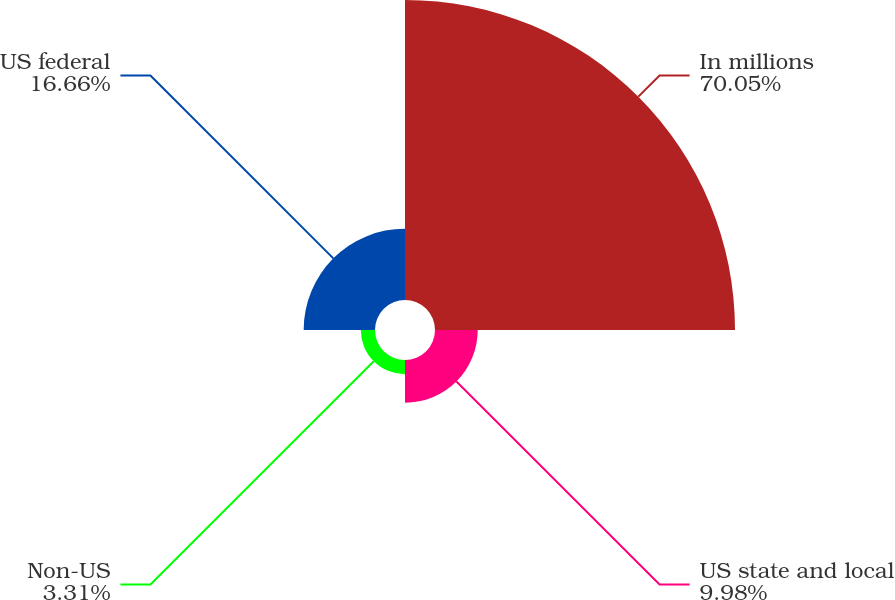Convert chart to OTSL. <chart><loc_0><loc_0><loc_500><loc_500><pie_chart><fcel>In millions<fcel>US state and local<fcel>Non-US<fcel>US federal<nl><fcel>70.06%<fcel>9.98%<fcel>3.31%<fcel>16.66%<nl></chart> 